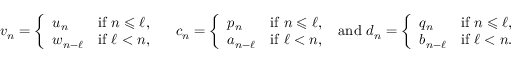<formula> <loc_0><loc_0><loc_500><loc_500>v _ { n } = \left \{ \begin{array} { l l } { u _ { n } } & { i f n \leqslant \ell , } \\ { w _ { n - \ell } } & { i f \ell < n , } \end{array} \quad c _ { n } = \left \{ \begin{array} { l l } { p _ { n } } & { i f n \leqslant \ell , } \\ { a _ { n - \ell } } & { i f \ell < n , } \end{array} a n d d _ { n } = \left \{ \begin{array} { l l } { q _ { n } } & { i f n \leqslant \ell , } \\ { b _ { n - \ell } } & { i f \ell < n . } \end{array}</formula> 